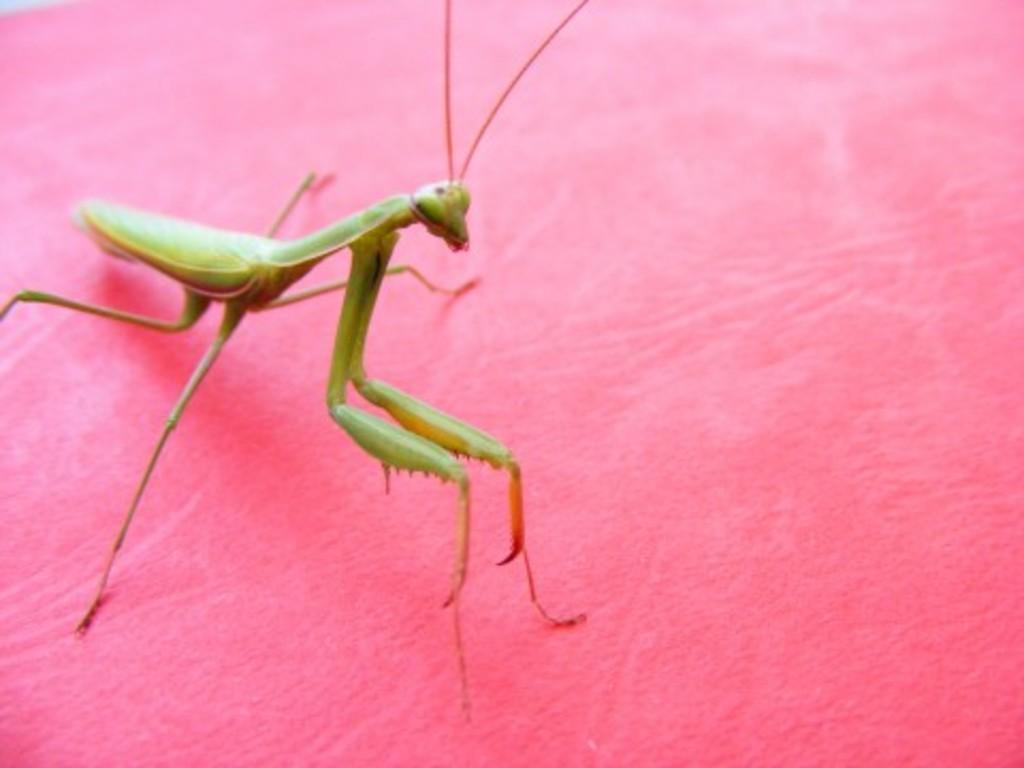How would you summarize this image in a sentence or two? In this image I can see a mantis which is green and orange in color on the pink colored surface. 